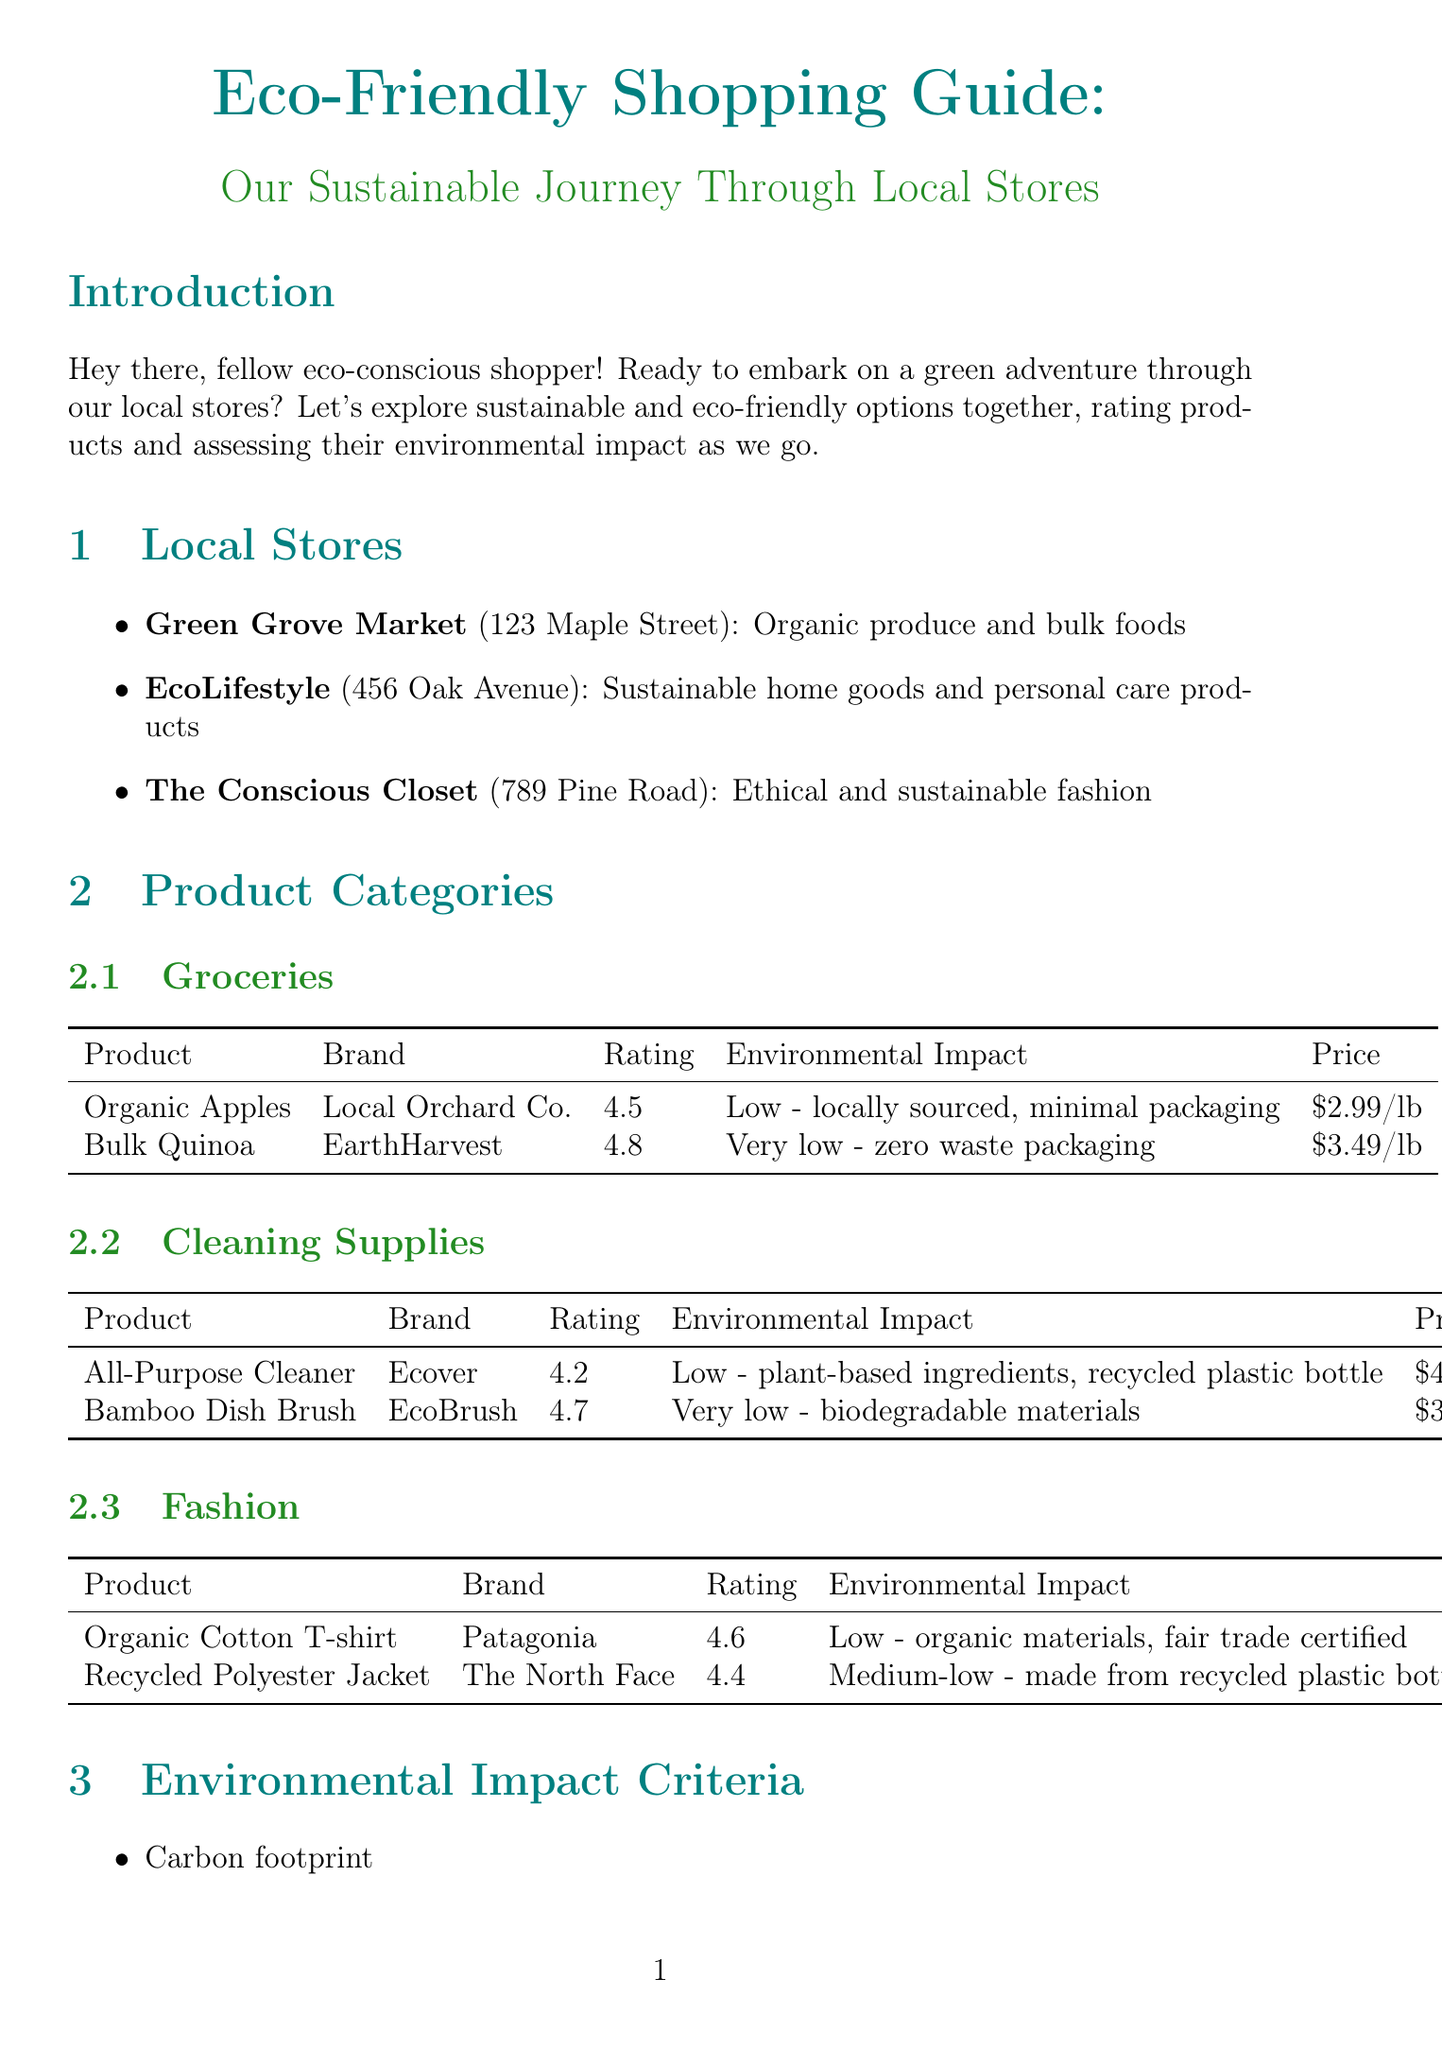What is the name of the store specializing in organic produce? The store focused on organic produce is listed as Green Grove Market.
Answer: Green Grove Market What is the rating of Bulk Quinoa? The rating for Bulk Quinoa is stated in the product section under Groceries, which is 4.8.
Answer: 4.8 What is the environmental impact of the All-Purpose Cleaner? The document provides details on the environmental impact, describing it as low due to plant-based ingredients and a recycled plastic bottle.
Answer: Low - plant-based ingredients, recycled plastic bottle What is the price of the Organic Cotton T-shirt? The price for the Organic Cotton T-shirt is mentioned in the Fashion category as $35.00.
Answer: $35.00 What are the two criteria listed for environmental impact assessment? The document describes multiple criteria for assessing environmental impact; two examples mentioned are carbon footprint and water usage.
Answer: Carbon footprint, water usage Which product has a very low environmental impact? The Bamboo Dish Brush is specifically noted for having a very low environmental impact due to its biodegradable materials.
Answer: Bamboo Dish Brush What is one shopping tip mentioned in the report? Several tips are provided, among them is bringing your own reusable bags and containers.
Answer: Bring your own reusable bags and containers Where is EcoLifestyle located? The location of EcoLifestyle is detailed as 456 Oak Avenue.
Answer: 456 Oak Avenue 